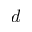<formula> <loc_0><loc_0><loc_500><loc_500>d</formula> 